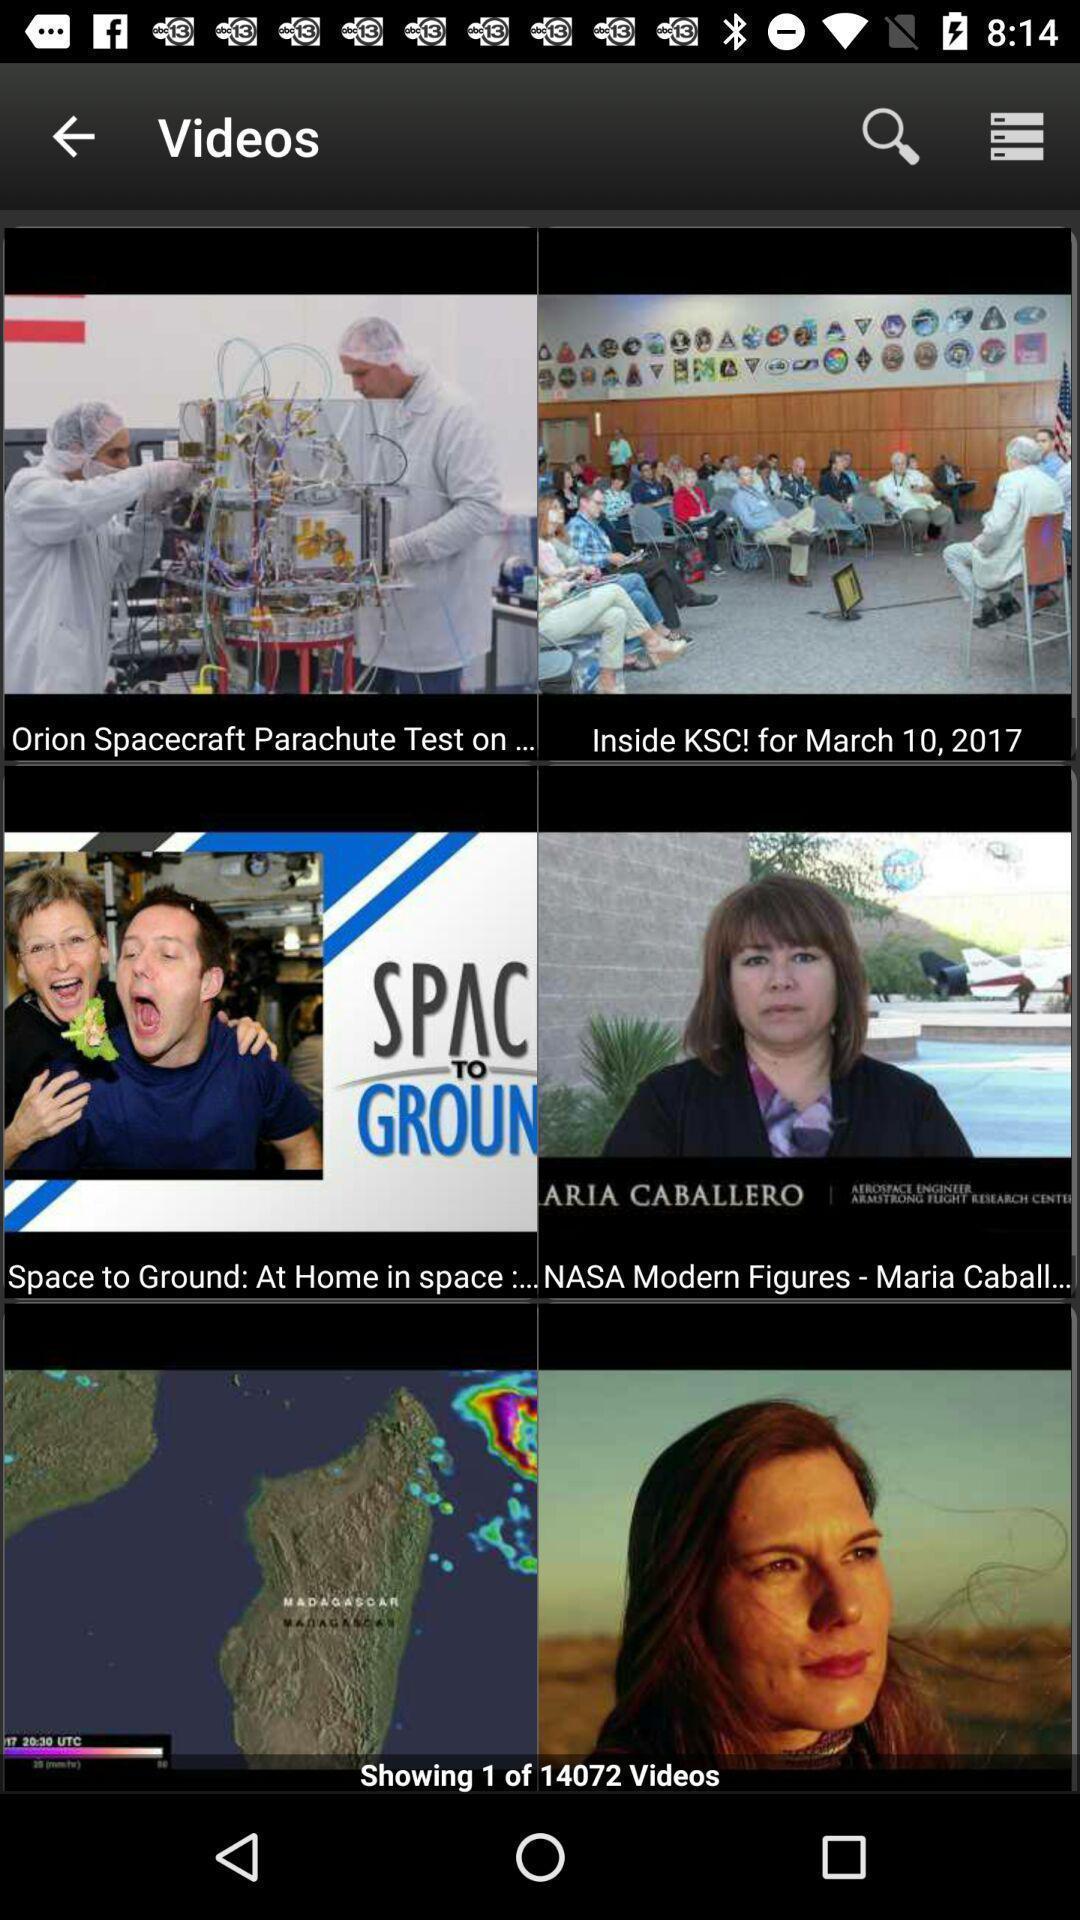What details can you identify in this image? Page with videos in a news app. 